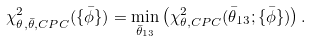Convert formula to latex. <formula><loc_0><loc_0><loc_500><loc_500>\chi ^ { 2 } _ { \theta , \bar { \theta } , C P C } ( \{ \bar { \phi } \} ) = \min _ { \bar { \theta } _ { 1 3 } } \left ( \chi ^ { 2 } _ { \theta , C P C } ( \bar { \theta } _ { 1 3 } ; \{ \bar { \phi } \} ) \right ) .</formula> 